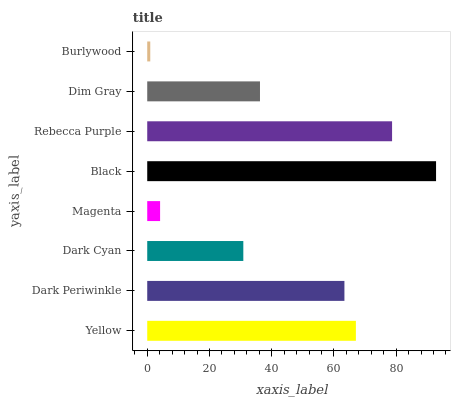Is Burlywood the minimum?
Answer yes or no. Yes. Is Black the maximum?
Answer yes or no. Yes. Is Dark Periwinkle the minimum?
Answer yes or no. No. Is Dark Periwinkle the maximum?
Answer yes or no. No. Is Yellow greater than Dark Periwinkle?
Answer yes or no. Yes. Is Dark Periwinkle less than Yellow?
Answer yes or no. Yes. Is Dark Periwinkle greater than Yellow?
Answer yes or no. No. Is Yellow less than Dark Periwinkle?
Answer yes or no. No. Is Dark Periwinkle the high median?
Answer yes or no. Yes. Is Dim Gray the low median?
Answer yes or no. Yes. Is Burlywood the high median?
Answer yes or no. No. Is Rebecca Purple the low median?
Answer yes or no. No. 